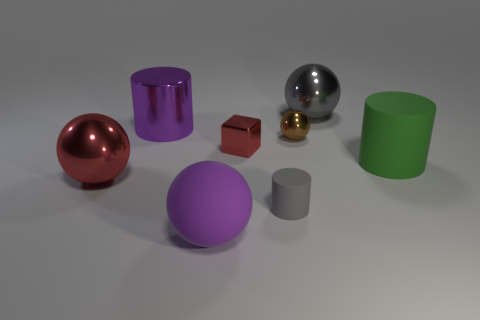Subtract all green spheres. Subtract all gray cubes. How many spheres are left? 4 Add 1 tiny blue metallic cubes. How many objects exist? 9 Subtract all cubes. How many objects are left? 7 Add 2 red metal balls. How many red metal balls are left? 3 Add 6 tiny purple cylinders. How many tiny purple cylinders exist? 6 Subtract 0 brown cylinders. How many objects are left? 8 Subtract all green cylinders. Subtract all large purple metal objects. How many objects are left? 6 